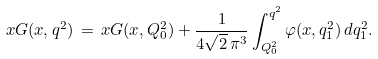Convert formula to latex. <formula><loc_0><loc_0><loc_500><loc_500>x G ( x , q ^ { 2 } ) \, = \, x G ( x , Q _ { 0 } ^ { 2 } ) + \frac { 1 } { 4 \sqrt { 2 } \, \pi ^ { 3 } } \int ^ { q ^ { 2 } } _ { Q _ { 0 } ^ { 2 } } \varphi ( x , q ^ { 2 } _ { 1 } ) \, d q _ { 1 } ^ { 2 } .</formula> 